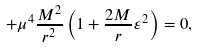Convert formula to latex. <formula><loc_0><loc_0><loc_500><loc_500>+ \mu ^ { 4 } \frac { M ^ { 2 } } { r ^ { 2 } } \left ( 1 + \frac { 2 M } { r } \varepsilon ^ { 2 } \right ) = 0 ,</formula> 